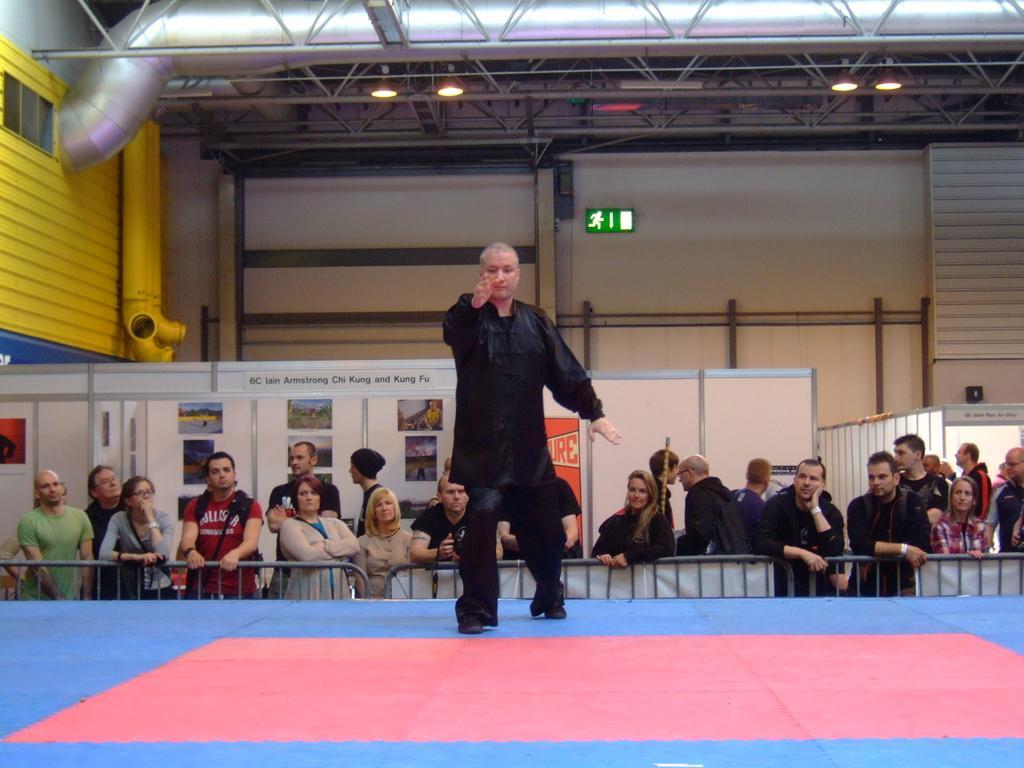Could you give a brief overview of what you see in this image? In the center of the image we can see a man standing. In the background there are people, fence, boards and a wall. At the top there are lights. 